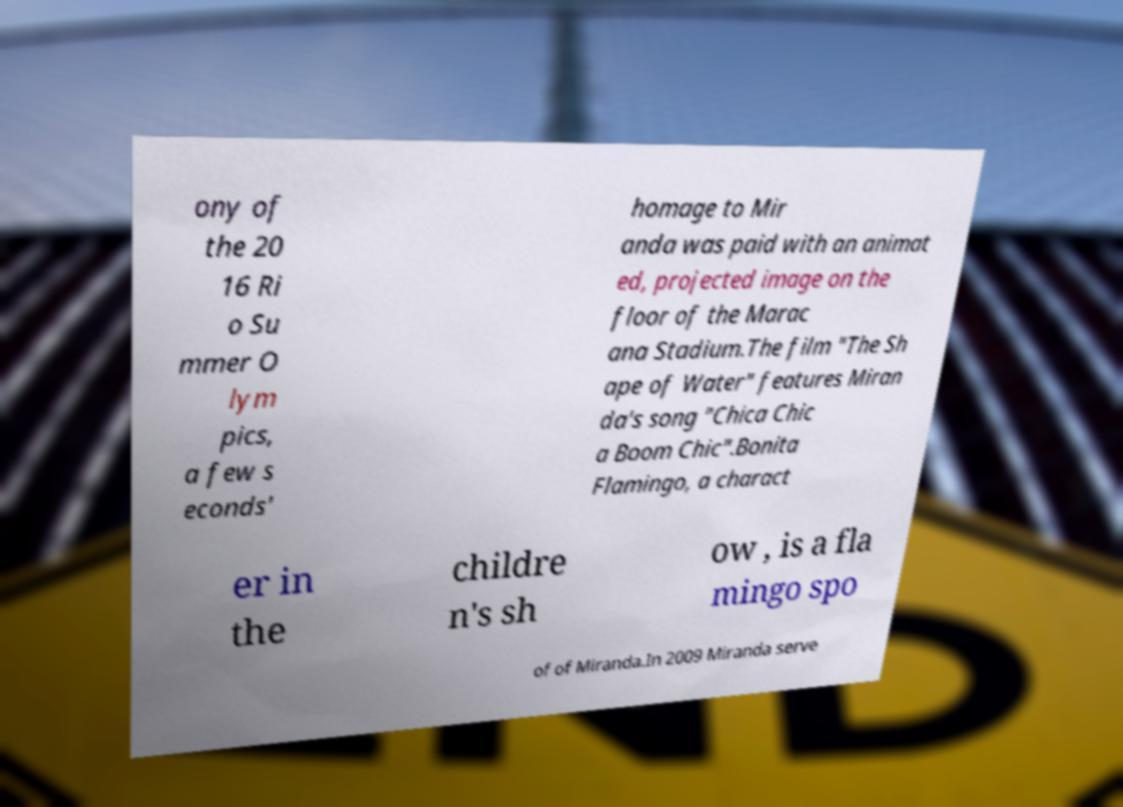Can you accurately transcribe the text from the provided image for me? ony of the 20 16 Ri o Su mmer O lym pics, a few s econds' homage to Mir anda was paid with an animat ed, projected image on the floor of the Marac ana Stadium.The film "The Sh ape of Water" features Miran da's song "Chica Chic a Boom Chic".Bonita Flamingo, a charact er in the childre n's sh ow , is a fla mingo spo of of Miranda.In 2009 Miranda serve 